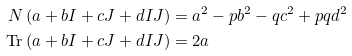<formula> <loc_0><loc_0><loc_500><loc_500>N \left ( a + b I + c J + d I J \right ) & = a ^ { 2 } - p b ^ { 2 } - q c ^ { 2 } + p q d ^ { 2 } \\ \text {Tr} \left ( a + b I + c J + d I J \right ) & = 2 a</formula> 